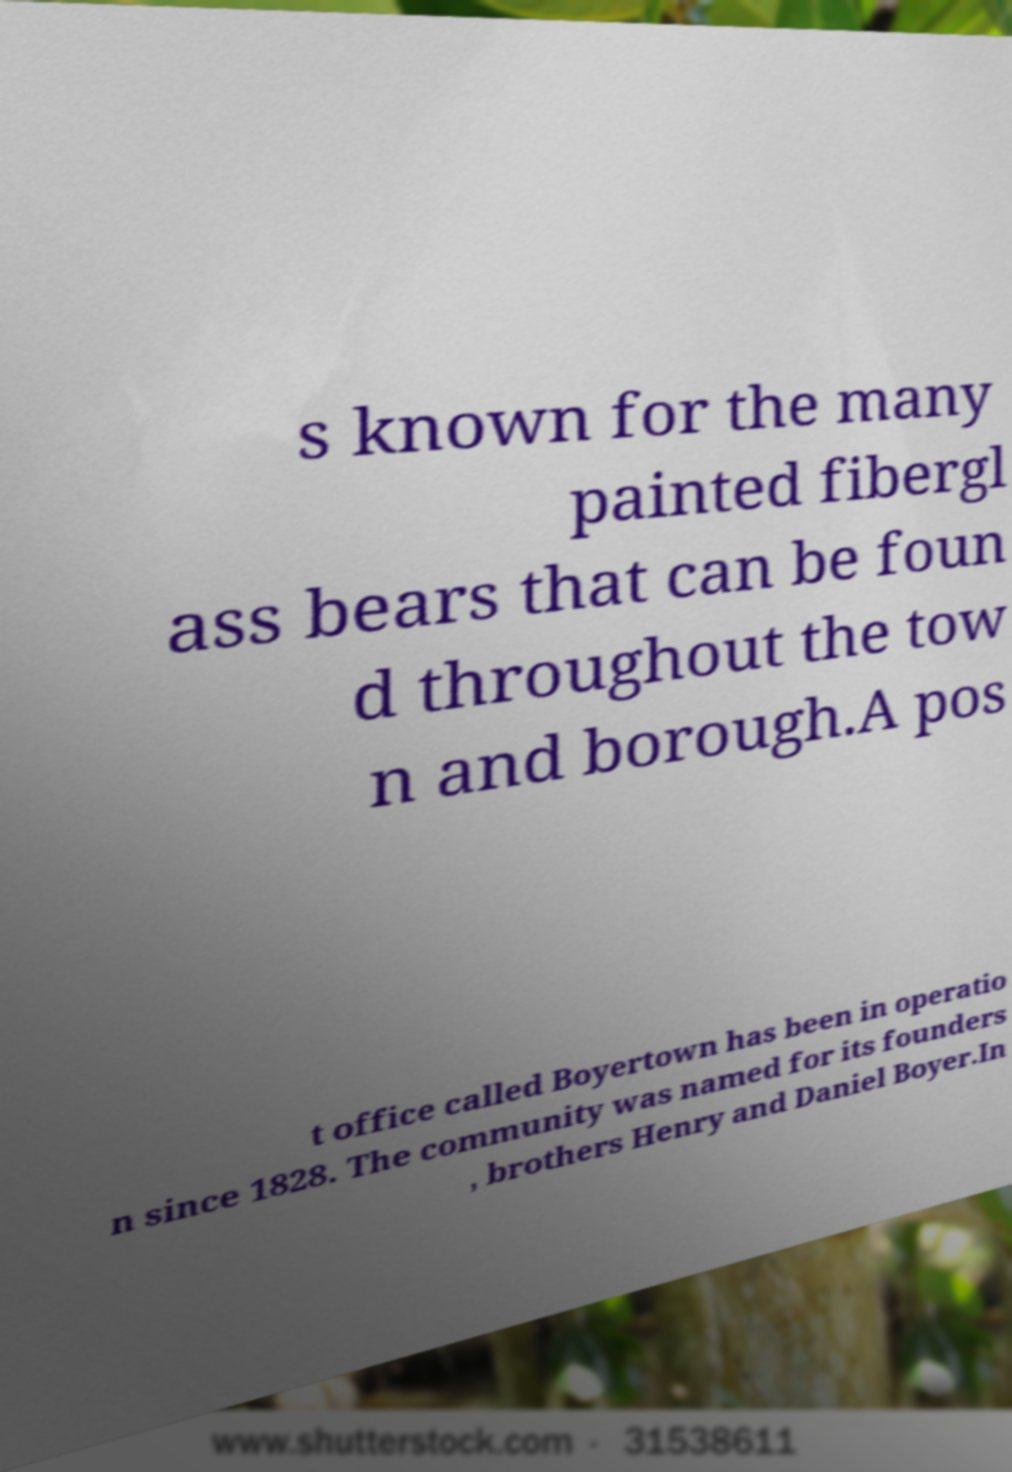For documentation purposes, I need the text within this image transcribed. Could you provide that? s known for the many painted fibergl ass bears that can be foun d throughout the tow n and borough.A pos t office called Boyertown has been in operatio n since 1828. The community was named for its founders , brothers Henry and Daniel Boyer.In 